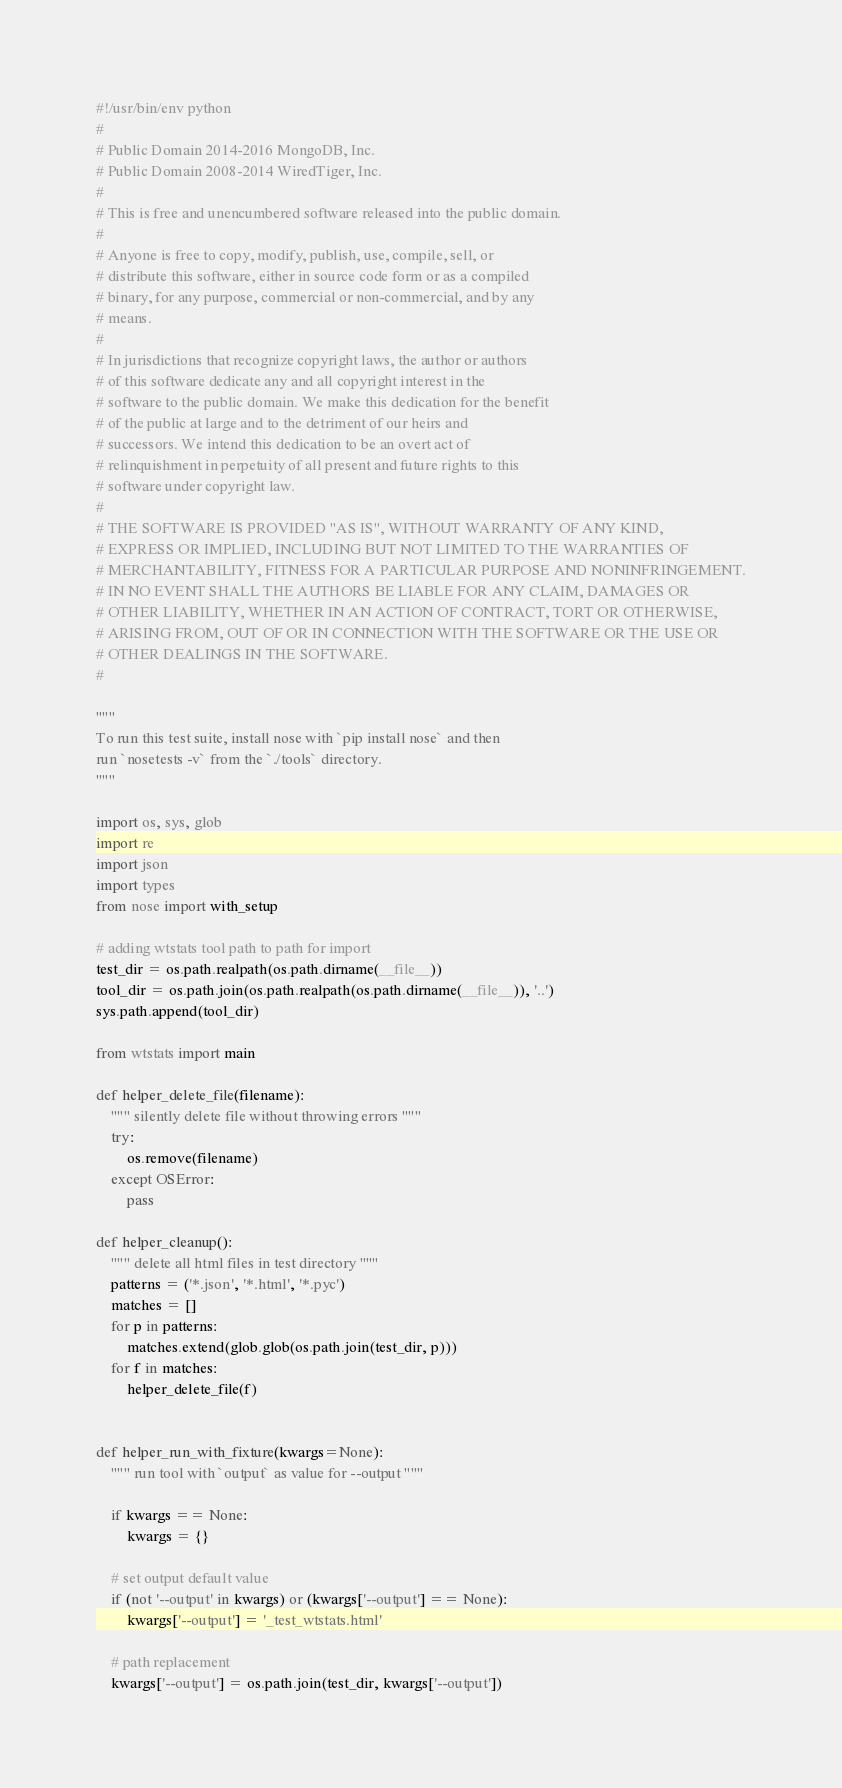Convert code to text. <code><loc_0><loc_0><loc_500><loc_500><_Python_>#!/usr/bin/env python
#
# Public Domain 2014-2016 MongoDB, Inc.
# Public Domain 2008-2014 WiredTiger, Inc.
#
# This is free and unencumbered software released into the public domain.
#
# Anyone is free to copy, modify, publish, use, compile, sell, or
# distribute this software, either in source code form or as a compiled
# binary, for any purpose, commercial or non-commercial, and by any
# means.
#
# In jurisdictions that recognize copyright laws, the author or authors
# of this software dedicate any and all copyright interest in the
# software to the public domain. We make this dedication for the benefit
# of the public at large and to the detriment of our heirs and
# successors. We intend this dedication to be an overt act of
# relinquishment in perpetuity of all present and future rights to this
# software under copyright law.
#
# THE SOFTWARE IS PROVIDED "AS IS", WITHOUT WARRANTY OF ANY KIND,
# EXPRESS OR IMPLIED, INCLUDING BUT NOT LIMITED TO THE WARRANTIES OF
# MERCHANTABILITY, FITNESS FOR A PARTICULAR PURPOSE AND NONINFRINGEMENT.
# IN NO EVENT SHALL THE AUTHORS BE LIABLE FOR ANY CLAIM, DAMAGES OR
# OTHER LIABILITY, WHETHER IN AN ACTION OF CONTRACT, TORT OR OTHERWISE,
# ARISING FROM, OUT OF OR IN CONNECTION WITH THE SOFTWARE OR THE USE OR
# OTHER DEALINGS IN THE SOFTWARE.
#

""" 
To run this test suite, install nose with `pip install nose` and then
run `nosetests -v` from the `./tools` directory.
"""

import os, sys, glob
import re
import json
import types
from nose import with_setup

# adding wtstats tool path to path for import
test_dir = os.path.realpath(os.path.dirname(__file__))
tool_dir = os.path.join(os.path.realpath(os.path.dirname(__file__)), '..')
sys.path.append(tool_dir)

from wtstats import main

def helper_delete_file(filename):
    """ silently delete file without throwing errors """
    try:
        os.remove(filename)
    except OSError:
        pass

def helper_cleanup():
    """ delete all html files in test directory """
    patterns = ('*.json', '*.html', '*.pyc')
    matches = []
    for p in patterns:
        matches.extend(glob.glob(os.path.join(test_dir, p)))
    for f in matches: 
        helper_delete_file(f)


def helper_run_with_fixture(kwargs=None):
    """ run tool with `output` as value for --output """
    
    if kwargs == None:
        kwargs = {}

    # set output default value
    if (not '--output' in kwargs) or (kwargs['--output'] == None):
        kwargs['--output'] = '_test_wtstats.html'

    # path replacement
    kwargs['--output'] = os.path.join(test_dir, kwargs['--output'])
</code> 